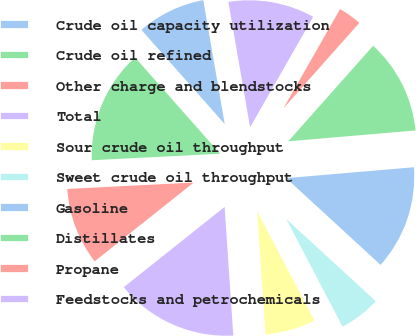Convert chart. <chart><loc_0><loc_0><loc_500><loc_500><pie_chart><fcel>Crude oil capacity utilization<fcel>Crude oil refined<fcel>Other charge and blendstocks<fcel>Total<fcel>Sour crude oil throughput<fcel>Sweet crude oil throughput<fcel>Gasoline<fcel>Distillates<fcel>Propane<fcel>Feedstocks and petrochemicals<nl><fcel>8.79%<fcel>14.28%<fcel>9.89%<fcel>15.38%<fcel>6.6%<fcel>5.5%<fcel>13.18%<fcel>12.09%<fcel>3.3%<fcel>10.99%<nl></chart> 